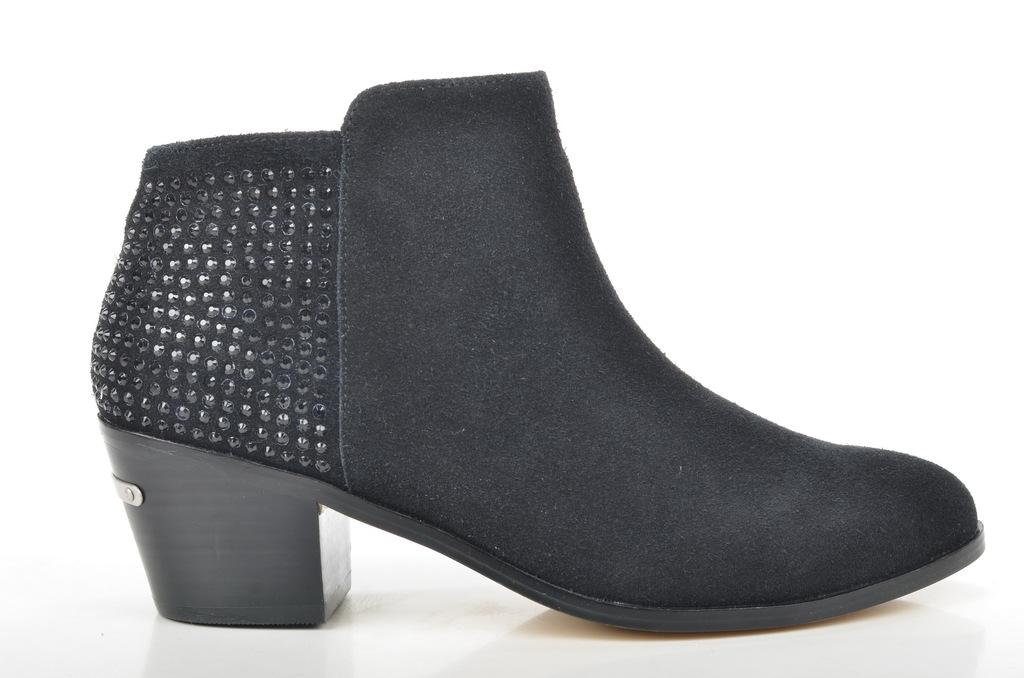What type of object is present in the image? There is a footwear in the image. What type of plant is growing near the scarecrow in the image? There is no scarecrow or plant present in the image; it only features footwear. 